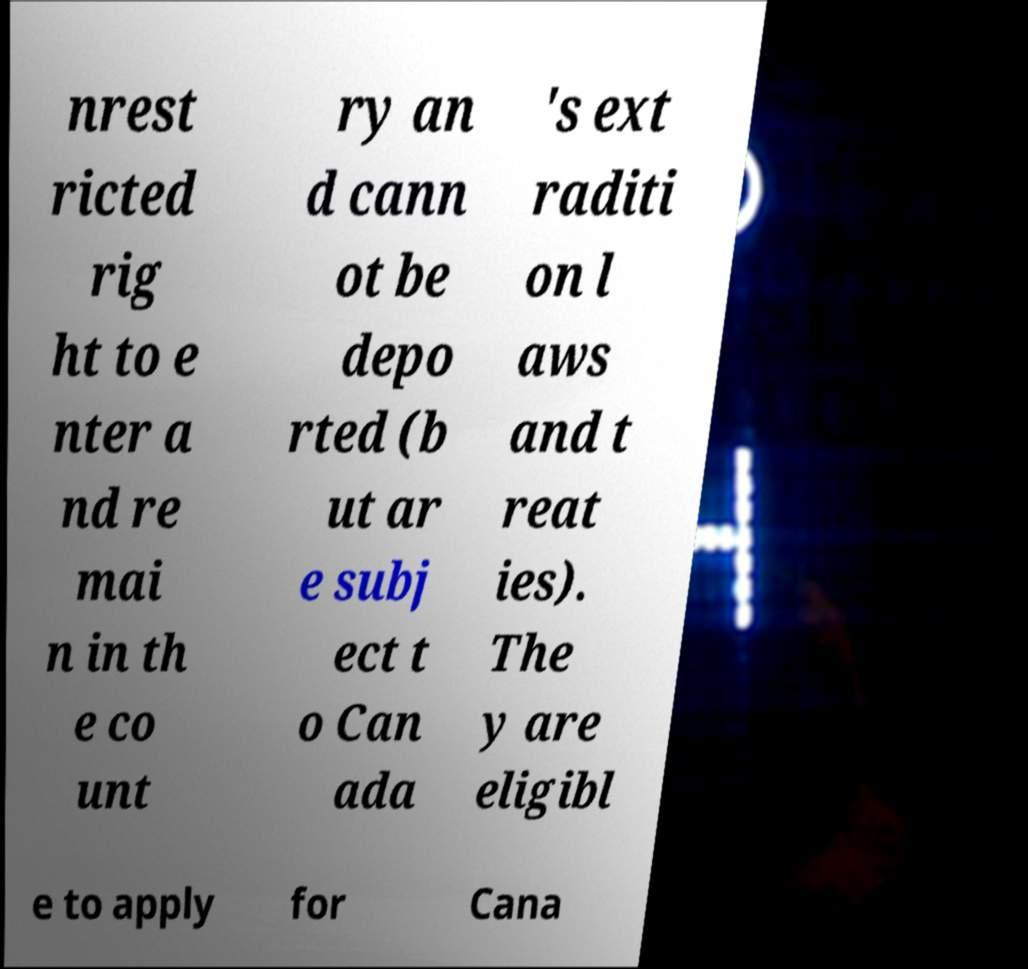Please read and relay the text visible in this image. What does it say? nrest ricted rig ht to e nter a nd re mai n in th e co unt ry an d cann ot be depo rted (b ut ar e subj ect t o Can ada 's ext raditi on l aws and t reat ies). The y are eligibl e to apply for Cana 